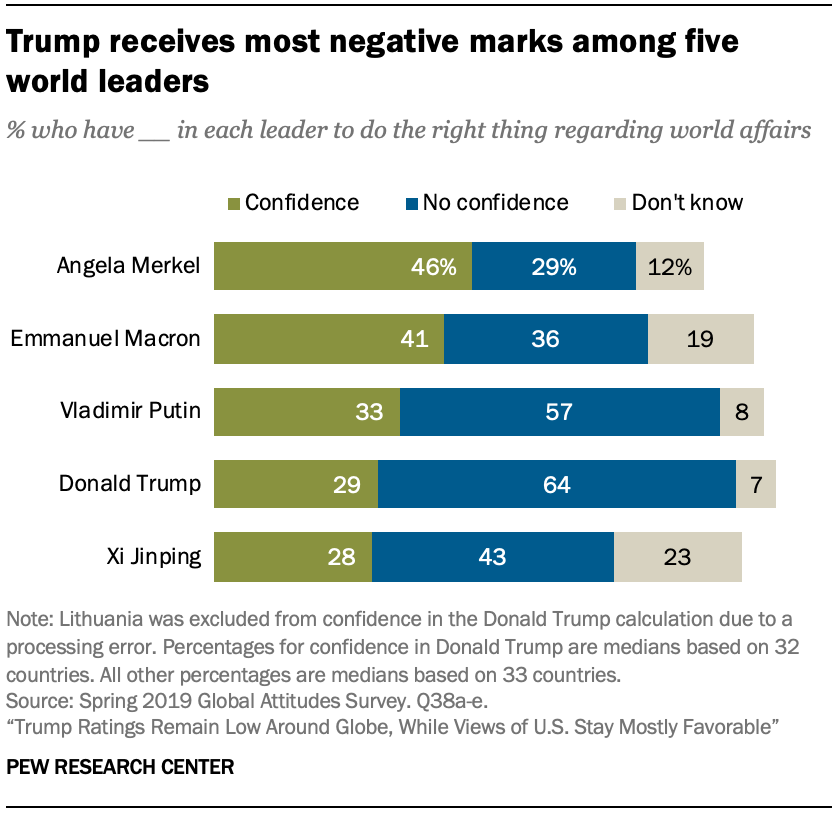Identify some key points in this picture. The value of Emmanuel Macron is higher than Vladimir Putin in the Confident list. Xi Jinping has the lowest score on the Confident list. 